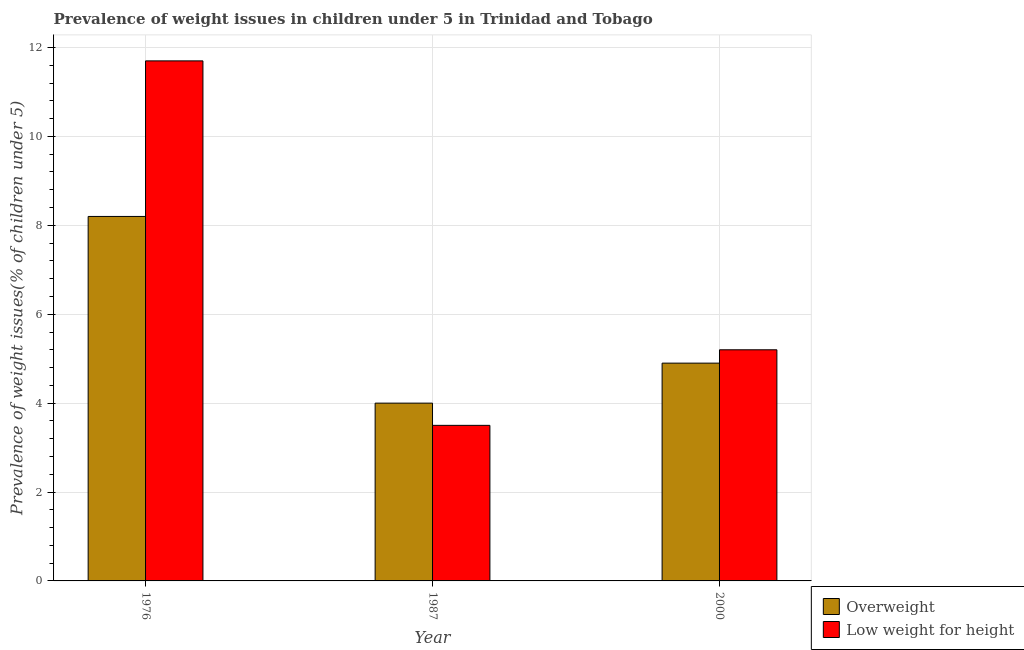Are the number of bars per tick equal to the number of legend labels?
Your answer should be compact. Yes. How many bars are there on the 2nd tick from the left?
Provide a short and direct response. 2. What is the percentage of overweight children in 2000?
Your response must be concise. 4.9. Across all years, what is the maximum percentage of overweight children?
Keep it short and to the point. 8.2. Across all years, what is the minimum percentage of underweight children?
Your answer should be compact. 3.5. In which year was the percentage of overweight children maximum?
Give a very brief answer. 1976. What is the total percentage of overweight children in the graph?
Offer a terse response. 17.1. What is the difference between the percentage of underweight children in 1976 and that in 1987?
Provide a succinct answer. 8.2. What is the difference between the percentage of overweight children in 1987 and the percentage of underweight children in 2000?
Keep it short and to the point. -0.9. What is the average percentage of overweight children per year?
Offer a terse response. 5.7. In how many years, is the percentage of overweight children greater than 4.8 %?
Make the answer very short. 2. What is the ratio of the percentage of underweight children in 1976 to that in 2000?
Offer a very short reply. 2.25. Is the percentage of underweight children in 1976 less than that in 2000?
Make the answer very short. No. Is the difference between the percentage of underweight children in 1987 and 2000 greater than the difference between the percentage of overweight children in 1987 and 2000?
Your answer should be very brief. No. What is the difference between the highest and the second highest percentage of overweight children?
Provide a succinct answer. 3.3. What is the difference between the highest and the lowest percentage of underweight children?
Your response must be concise. 8.2. Is the sum of the percentage of underweight children in 1976 and 2000 greater than the maximum percentage of overweight children across all years?
Give a very brief answer. Yes. What does the 2nd bar from the left in 1976 represents?
Offer a terse response. Low weight for height. What does the 2nd bar from the right in 1987 represents?
Provide a short and direct response. Overweight. What is the difference between two consecutive major ticks on the Y-axis?
Give a very brief answer. 2. Are the values on the major ticks of Y-axis written in scientific E-notation?
Ensure brevity in your answer.  No. Does the graph contain any zero values?
Provide a succinct answer. No. Where does the legend appear in the graph?
Ensure brevity in your answer.  Bottom right. What is the title of the graph?
Give a very brief answer. Prevalence of weight issues in children under 5 in Trinidad and Tobago. Does "Public credit registry" appear as one of the legend labels in the graph?
Ensure brevity in your answer.  No. What is the label or title of the X-axis?
Provide a short and direct response. Year. What is the label or title of the Y-axis?
Provide a succinct answer. Prevalence of weight issues(% of children under 5). What is the Prevalence of weight issues(% of children under 5) of Overweight in 1976?
Your answer should be very brief. 8.2. What is the Prevalence of weight issues(% of children under 5) in Low weight for height in 1976?
Offer a terse response. 11.7. What is the Prevalence of weight issues(% of children under 5) in Overweight in 2000?
Make the answer very short. 4.9. What is the Prevalence of weight issues(% of children under 5) of Low weight for height in 2000?
Make the answer very short. 5.2. Across all years, what is the maximum Prevalence of weight issues(% of children under 5) in Overweight?
Offer a terse response. 8.2. Across all years, what is the maximum Prevalence of weight issues(% of children under 5) of Low weight for height?
Offer a very short reply. 11.7. What is the total Prevalence of weight issues(% of children under 5) of Low weight for height in the graph?
Your answer should be very brief. 20.4. What is the difference between the Prevalence of weight issues(% of children under 5) in Overweight in 1976 and that in 1987?
Your response must be concise. 4.2. What is the difference between the Prevalence of weight issues(% of children under 5) in Low weight for height in 1976 and that in 1987?
Your answer should be very brief. 8.2. What is the difference between the Prevalence of weight issues(% of children under 5) of Overweight in 1976 and that in 2000?
Offer a very short reply. 3.3. What is the difference between the Prevalence of weight issues(% of children under 5) in Overweight in 1987 and that in 2000?
Keep it short and to the point. -0.9. What is the difference between the Prevalence of weight issues(% of children under 5) in Overweight in 1987 and the Prevalence of weight issues(% of children under 5) in Low weight for height in 2000?
Keep it short and to the point. -1.2. What is the average Prevalence of weight issues(% of children under 5) in Low weight for height per year?
Make the answer very short. 6.8. What is the ratio of the Prevalence of weight issues(% of children under 5) of Overweight in 1976 to that in 1987?
Ensure brevity in your answer.  2.05. What is the ratio of the Prevalence of weight issues(% of children under 5) in Low weight for height in 1976 to that in 1987?
Provide a short and direct response. 3.34. What is the ratio of the Prevalence of weight issues(% of children under 5) in Overweight in 1976 to that in 2000?
Your response must be concise. 1.67. What is the ratio of the Prevalence of weight issues(% of children under 5) in Low weight for height in 1976 to that in 2000?
Provide a succinct answer. 2.25. What is the ratio of the Prevalence of weight issues(% of children under 5) in Overweight in 1987 to that in 2000?
Keep it short and to the point. 0.82. What is the ratio of the Prevalence of weight issues(% of children under 5) in Low weight for height in 1987 to that in 2000?
Give a very brief answer. 0.67. What is the difference between the highest and the second highest Prevalence of weight issues(% of children under 5) of Low weight for height?
Keep it short and to the point. 6.5. What is the difference between the highest and the lowest Prevalence of weight issues(% of children under 5) of Low weight for height?
Provide a succinct answer. 8.2. 